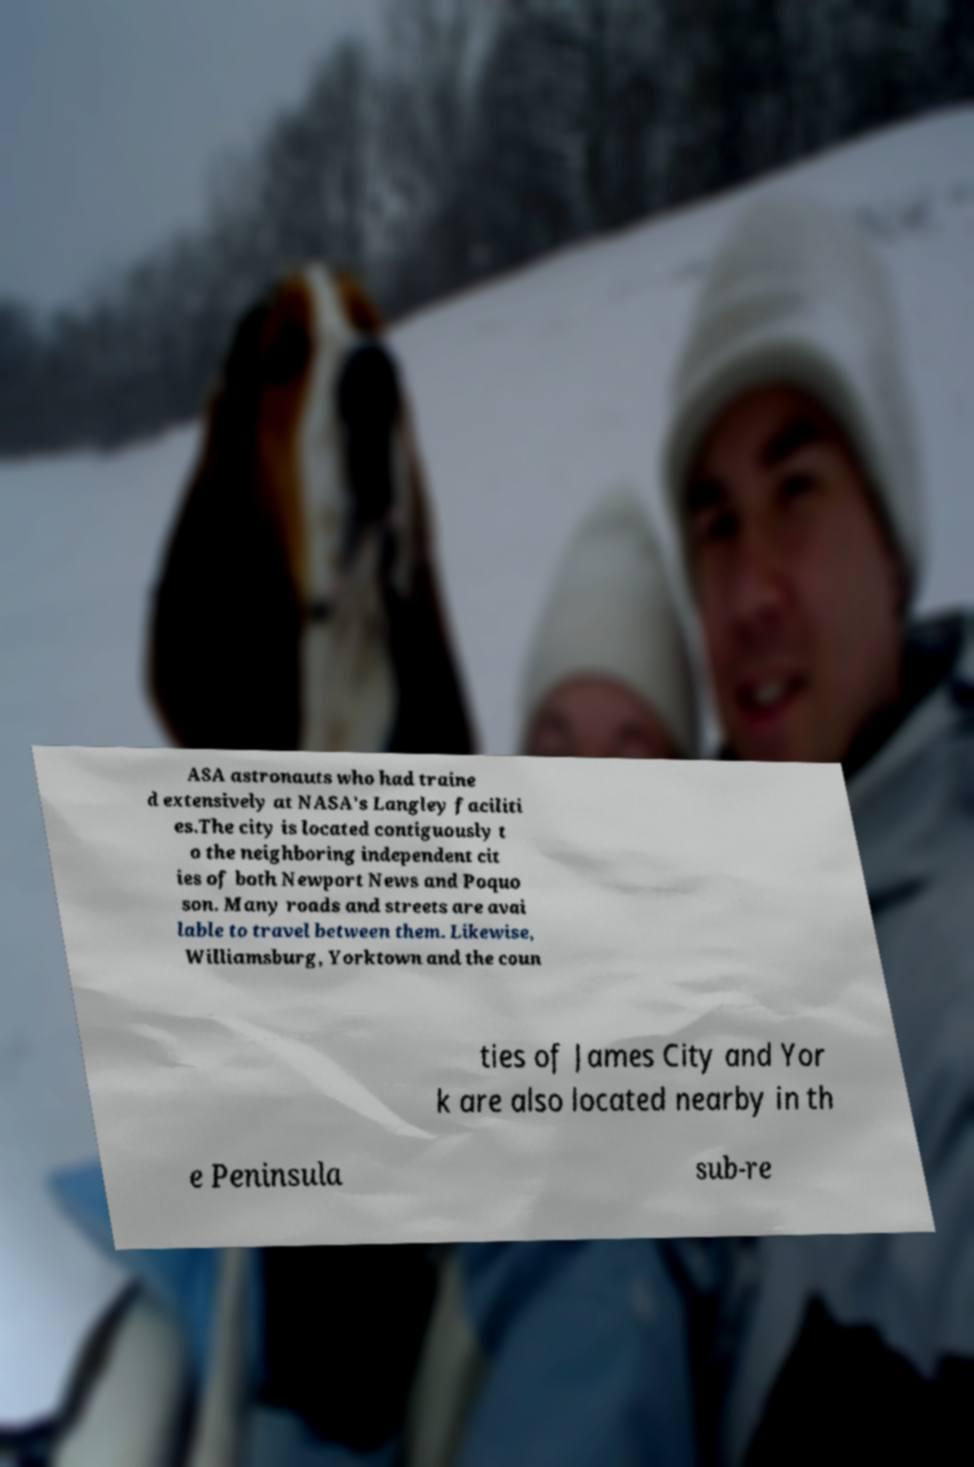Could you assist in decoding the text presented in this image and type it out clearly? ASA astronauts who had traine d extensively at NASA's Langley faciliti es.The city is located contiguously t o the neighboring independent cit ies of both Newport News and Poquo son. Many roads and streets are avai lable to travel between them. Likewise, Williamsburg, Yorktown and the coun ties of James City and Yor k are also located nearby in th e Peninsula sub-re 